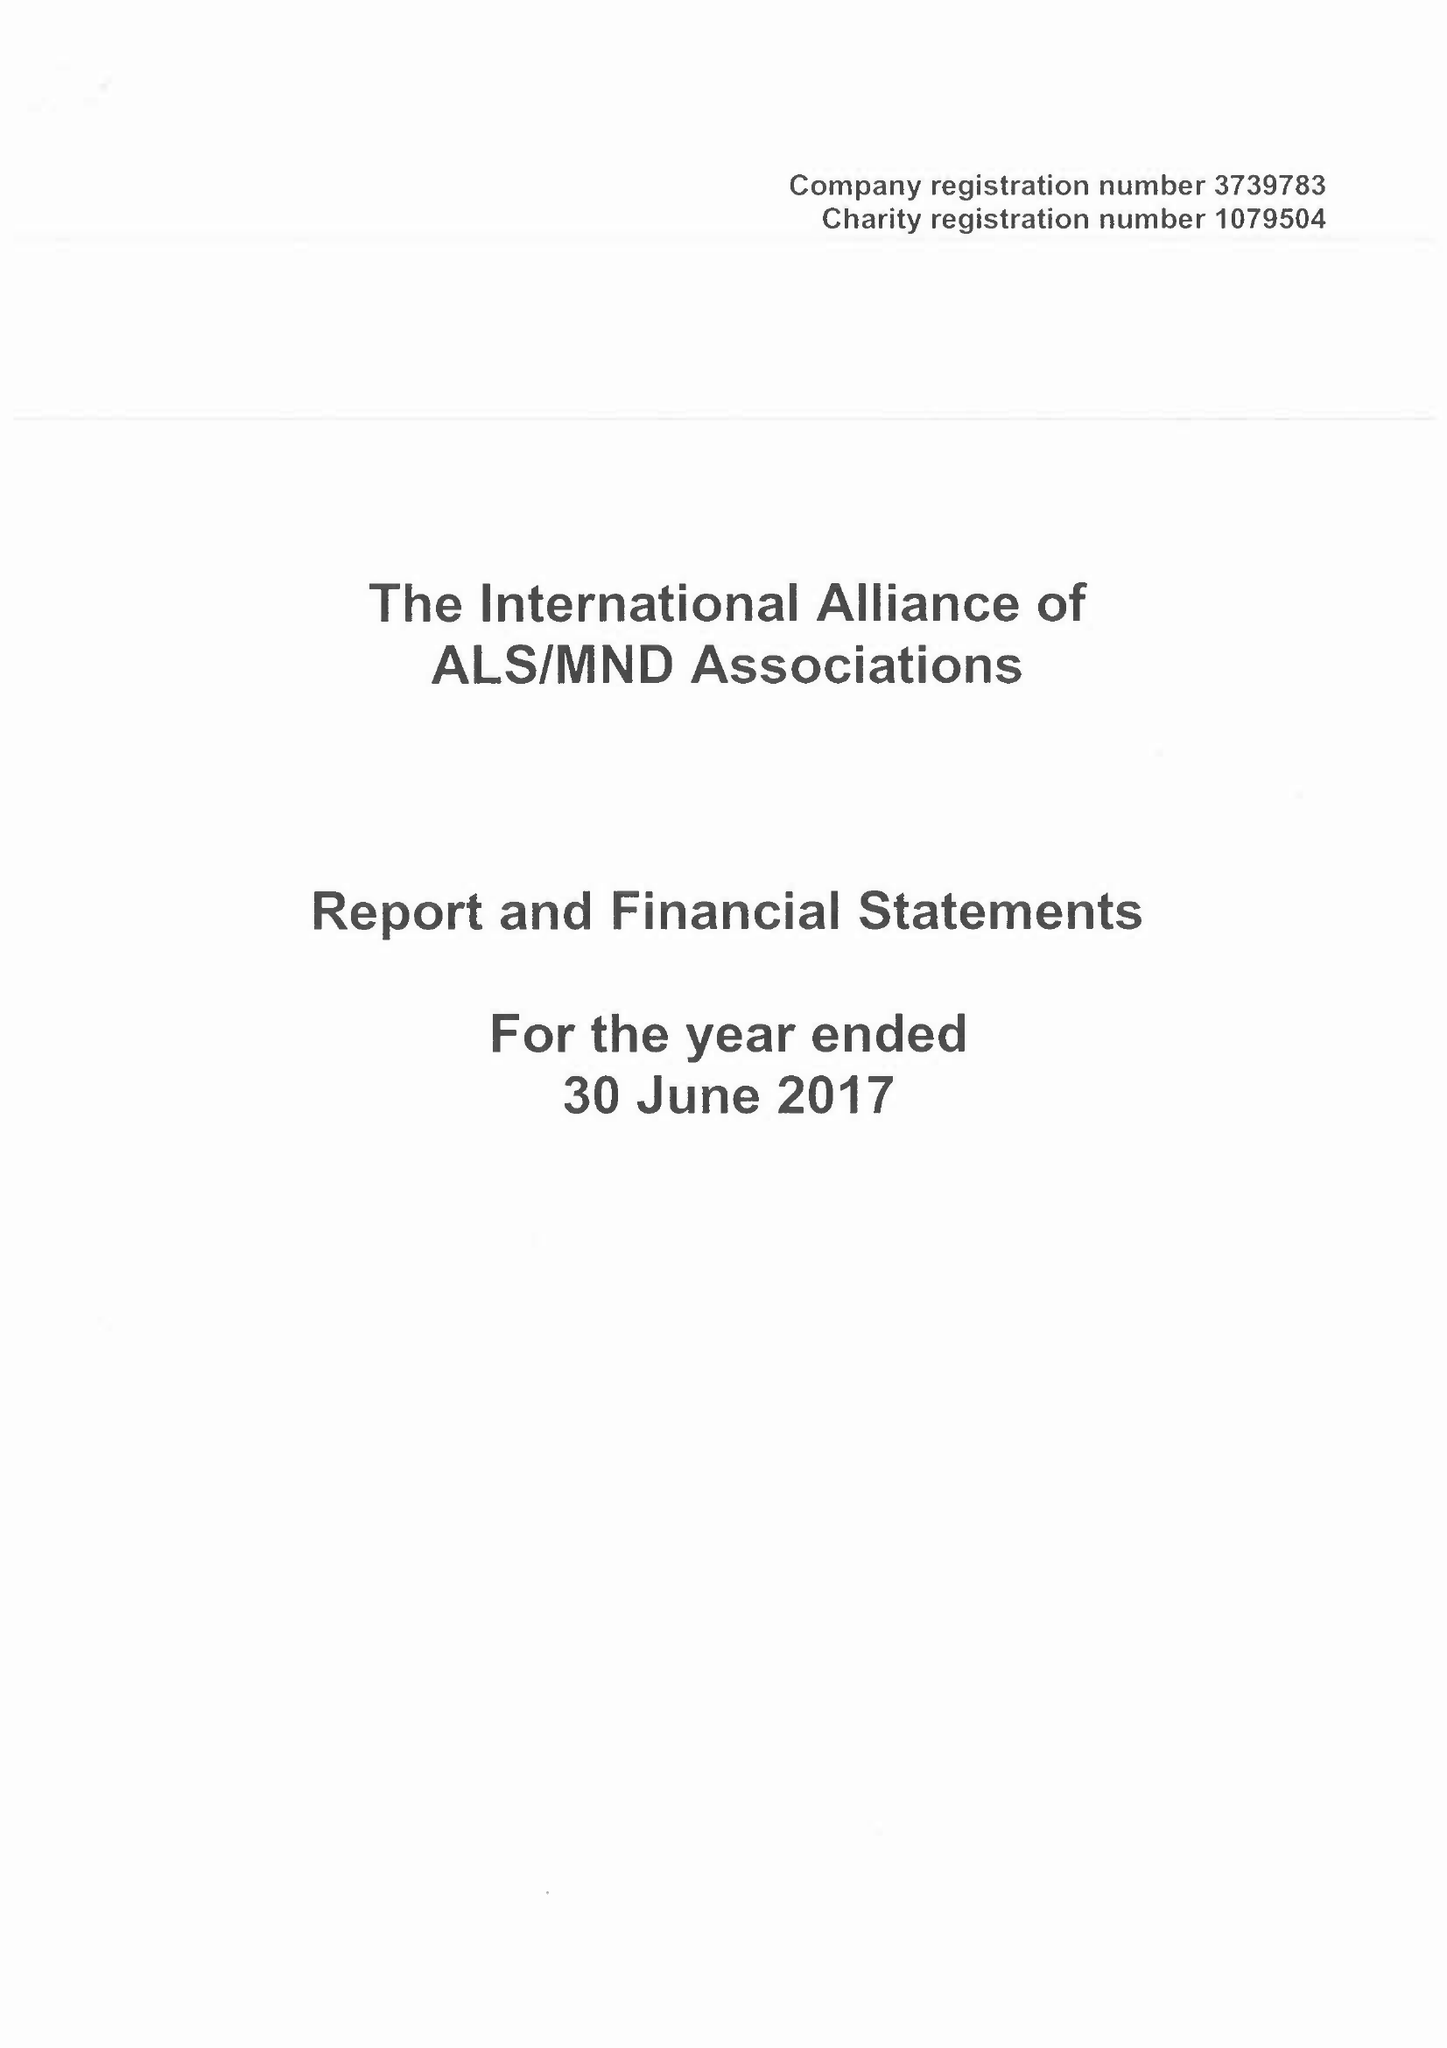What is the value for the charity_number?
Answer the question using a single word or phrase. 1079504 